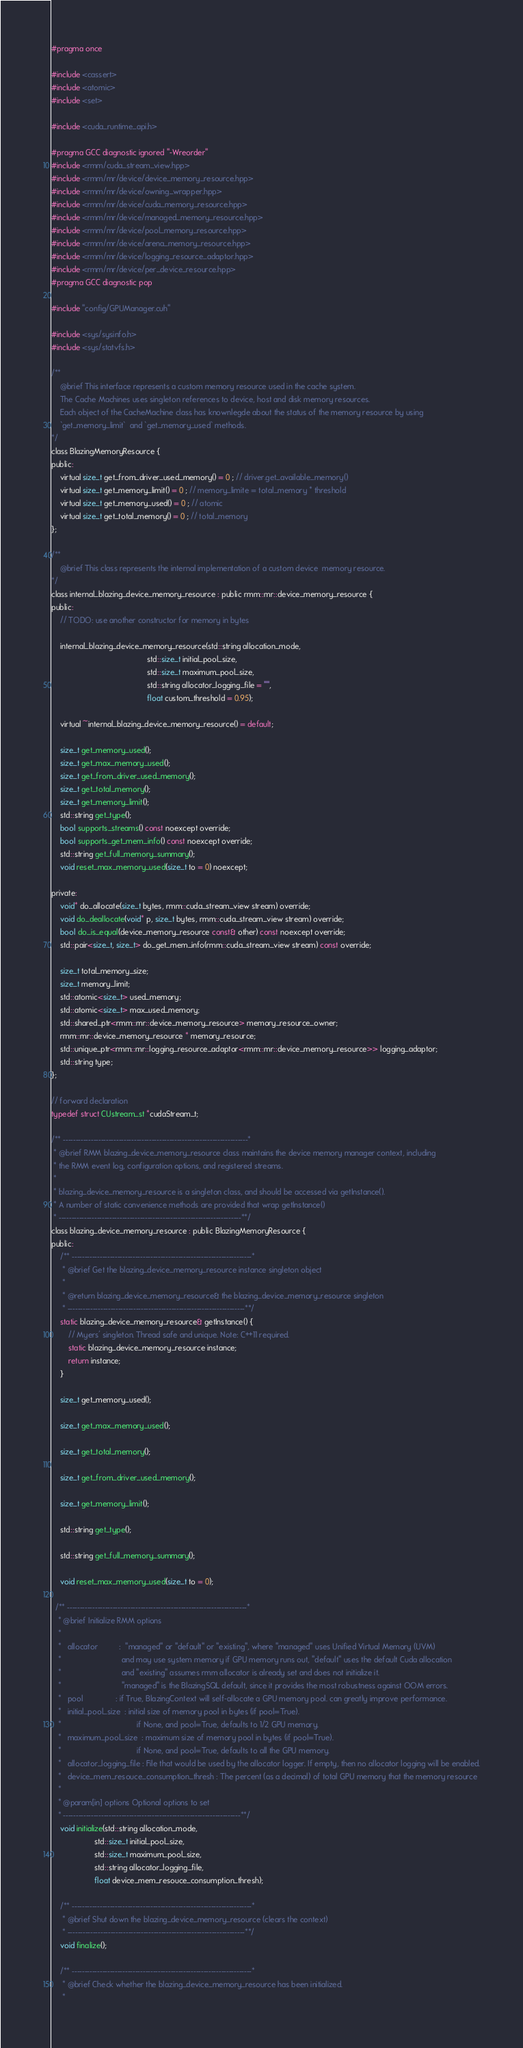Convert code to text. <code><loc_0><loc_0><loc_500><loc_500><_C_>#pragma once 

#include <cassert>
#include <atomic>
#include <set>

#include <cuda_runtime_api.h>

#pragma GCC diagnostic ignored "-Wreorder"
#include <rmm/cuda_stream_view.hpp>
#include <rmm/mr/device/device_memory_resource.hpp>
#include <rmm/mr/device/owning_wrapper.hpp>
#include <rmm/mr/device/cuda_memory_resource.hpp>
#include <rmm/mr/device/managed_memory_resource.hpp>
#include <rmm/mr/device/pool_memory_resource.hpp>
#include <rmm/mr/device/arena_memory_resource.hpp>
#include <rmm/mr/device/logging_resource_adaptor.hpp>
#include <rmm/mr/device/per_device_resource.hpp>
#pragma GCC diagnostic pop

#include "config/GPUManager.cuh"

#include <sys/sysinfo.h>
#include <sys/statvfs.h>

/**
    @brief This interface represents a custom memory resource used in the cache system.
    The Cache Machines uses singleton references to device, host and disk memory resources. 
    Each object of the CacheMachine class has knownlegde about the status of the memory resource by using
    `get_memory_limit`  and `get_memory_used` methods.
*/
class BlazingMemoryResource {
public:
    virtual size_t get_from_driver_used_memory() = 0 ; // driver.get_available_memory()
    virtual size_t get_memory_limit() = 0 ; // memory_limite = total_memory * threshold
    virtual size_t get_memory_used() = 0 ; // atomic 
    virtual size_t get_total_memory() = 0 ; // total_memory
};

/**
	@brief This class represents the internal implementation of a custom device  memory resource.
*/
class internal_blazing_device_memory_resource : public rmm::mr::device_memory_resource { 
public:
    // TODO: use another constructor for memory in bytes

    internal_blazing_device_memory_resource(std::string allocation_mode,
                                            std::size_t initial_pool_size,
                                            std::size_t maximum_pool_size,
                                            std::string allocator_logging_file = "",
                                            float custom_threshold = 0.95);

    virtual ~internal_blazing_device_memory_resource() = default;

    size_t get_memory_used();
    size_t get_max_memory_used();
    size_t get_from_driver_used_memory();
    size_t get_total_memory();
    size_t get_memory_limit();
    std::string get_type();
    bool supports_streams() const noexcept override;
    bool supports_get_mem_info() const noexcept override;
    std::string get_full_memory_summary();
    void reset_max_memory_used(size_t to = 0) noexcept;

private:
    void* do_allocate(size_t bytes, rmm::cuda_stream_view stream) override;
    void do_deallocate(void* p, size_t bytes, rmm::cuda_stream_view stream) override;
    bool do_is_equal(device_memory_resource const& other) const noexcept override;
    std::pair<size_t, size_t> do_get_mem_info(rmm::cuda_stream_view stream) const override;

    size_t total_memory_size;
    size_t memory_limit;
    std::atomic<size_t> used_memory;
    std::atomic<size_t> max_used_memory;
    std::shared_ptr<rmm::mr::device_memory_resource> memory_resource_owner;
    rmm::mr::device_memory_resource * memory_resource;
    std::unique_ptr<rmm::mr::logging_resource_adaptor<rmm::mr::device_memory_resource>> logging_adaptor;
    std::string type;
};

// forward declaration
typedef struct CUstream_st *cudaStream_t;

/** -------------------------------------------------------------------------*
 * @brief RMM blazing_device_memory_resource class maintains the device memory manager context, including
 * the RMM event log, configuration options, and registered streams.
 * 
 * blazing_device_memory_resource is a singleton class, and should be accessed via getInstance(). 
 * A number of static convenience methods are provided that wrap getInstance()
 * ------------------------------------------------------------------------**/
class blazing_device_memory_resource : public BlazingMemoryResource {
public:
    /** -----------------------------------------------------------------------*
     * @brief Get the blazing_device_memory_resource instance singleton object
     * 
     * @return blazing_device_memory_resource& the blazing_device_memory_resource singleton
     * ----------------------------------------------------------------------**/
    static blazing_device_memory_resource& getInstance() {
        // Myers' singleton. Thread safe and unique. Note: C++11 required.
        static blazing_device_memory_resource instance;
        return instance;
    }

    size_t get_memory_used();

    size_t get_max_memory_used();

    size_t get_total_memory();

    size_t get_from_driver_used_memory();

    size_t get_memory_limit();

    std::string get_type();

    std::string get_full_memory_summary();
    
    void reset_max_memory_used(size_t to = 0);

  /** -----------------------------------------------------------------------*
   * @brief Initialize RMM options
   * 
   *   allocator          :  "managed" or "default" or "existing", where "managed" uses Unified Virtual Memory (UVM)
   *                            and may use system memory if GPU memory runs out, "default" uses the default Cuda allocation
   *                            and "existing" assumes rmm allocator is already set and does not initialize it.
   *                            "managed" is the BlazingSQL default, since it provides the most robustness against OOM errors.
   *   pool               : if True, BlazingContext will self-allocate a GPU memory pool. can greatly improve performance.
   *   initial_pool_size  : initial size of memory pool in bytes (if pool=True).
   *                                   if None, and pool=True, defaults to 1/2 GPU memory.
   *   maximum_pool_size  : maximum size of memory pool in bytes (if pool=True).
   *                                   if None, and pool=True, defaults to all the GPU memory.
   *   allocator_logging_file : File that would be used by the allocator logger. If empty, then no allocator logging will be enabled.
   *   device_mem_resouce_consumption_thresh : The percent (as a decimal) of total GPU memory that the memory resource
   * 
   * @param[in] options Optional options to set
   * ----------------------------------------------------------------------**/
    void initialize(std::string allocation_mode,
                    std::size_t initial_pool_size,
                    std::size_t maximum_pool_size,
                    std::string allocator_logging_file,
                    float device_mem_resouce_consumption_thresh);

    /** -----------------------------------------------------------------------*
     * @brief Shut down the blazing_device_memory_resource (clears the context)
     * ----------------------------------------------------------------------**/
    void finalize();

    /** -----------------------------------------------------------------------*
     * @brief Check whether the blazing_device_memory_resource has been initialized.
     * </code> 